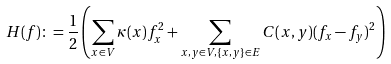<formula> <loc_0><loc_0><loc_500><loc_500>H ( f ) \colon = \frac { 1 } { 2 } \left ( \sum _ { x \in V } \kappa ( x ) f _ { x } ^ { 2 } + \sum _ { x , y \in V , \{ x , y \} \in E } C ( x , y ) ( f _ { x } - f _ { y } ) ^ { 2 } \right )</formula> 